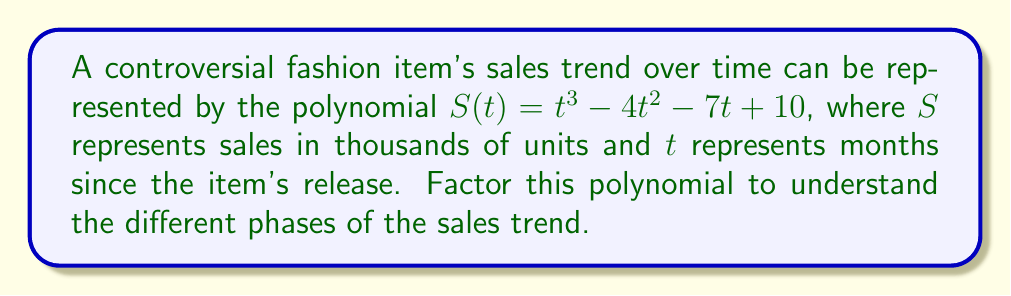Show me your answer to this math problem. To factor this polynomial, we'll follow these steps:

1) First, check if there's a common factor. In this case, there isn't.

2) Next, we'll use the rational root theorem to find potential roots. The factors of the constant term (10) are ±1, ±2, ±5, ±10.

3) Let's test these values:
   $S(1) = 1 - 4 - 7 + 10 = 0$
   We've found a root: $t = 1$

4) Now we can factor out $(t-1)$:
   $S(t) = (t-1)(t^2 + at + b)$

5) To find $a$ and $b$, we'll compare coefficients:
   $t^3 - 4t^2 - 7t + 10 = (t-1)(t^2 + at + b)$
   $t^3 - 4t^2 - 7t + 10 = t^3 + at^2 + bt - t^2 - at - b$

   Comparing coefficients:
   $-4 = a - 1$, so $a = -3$
   $-7 = b - a$, so $b = -10$

6) Our factored polynomial is now:
   $S(t) = (t-1)(t^2 - 3t - 10)$

7) The quadratic factor can be further factored:
   $t^2 - 3t - 10 = (t-5)(t+2)$

8) Therefore, the fully factored polynomial is:
   $S(t) = (t-1)(t-5)(t+2)$

This factorization reveals that the sales trend has three key points: when $t=1$, $t=5$, and $t=-2$ (which doesn't have a real-world interpretation in this context as time can't be negative).
Answer: $(t-1)(t-5)(t+2)$ 